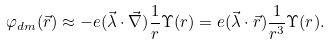Convert formula to latex. <formula><loc_0><loc_0><loc_500><loc_500>\varphi _ { d m } ( \vec { r } ) \approx - e ( \vec { \lambda } \cdot \vec { \nabla } ) \frac { 1 } { r } \Upsilon ( r ) = e ( \vec { \lambda } \cdot \vec { r } ) \frac { 1 } { r ^ { 3 } } \Upsilon ( r ) .</formula> 